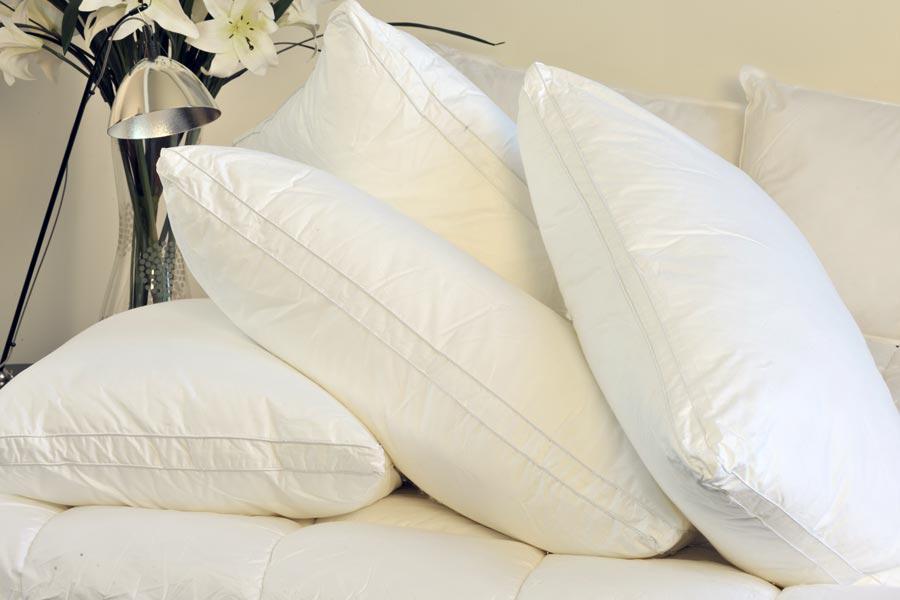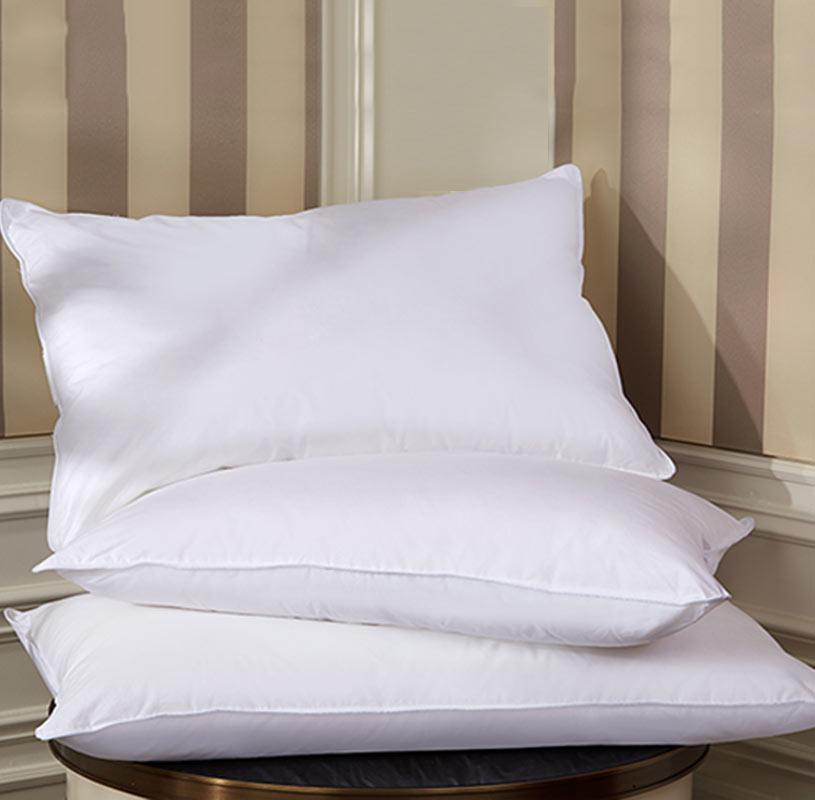The first image is the image on the left, the second image is the image on the right. Evaluate the accuracy of this statement regarding the images: "There are four white pillows on top of a white comforter.". Is it true? Answer yes or no. Yes. The first image is the image on the left, the second image is the image on the right. For the images shown, is this caption "The right image contains exactly three white pillows with smooth surfaces arranged overlapping but not stacked vertically." true? Answer yes or no. Yes. 